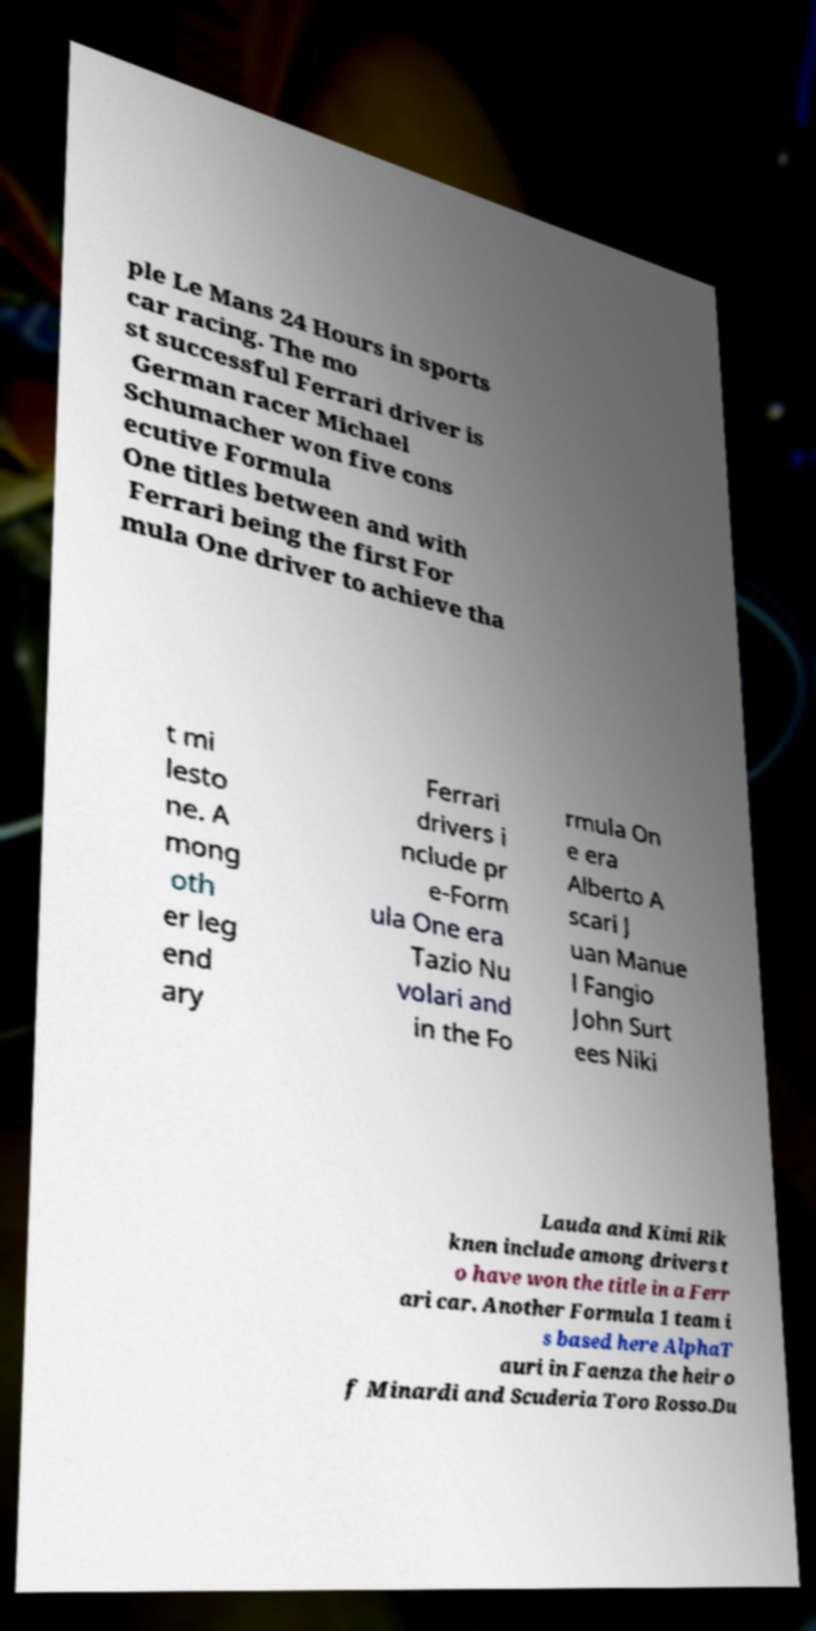Could you assist in decoding the text presented in this image and type it out clearly? ple Le Mans 24 Hours in sports car racing. The mo st successful Ferrari driver is German racer Michael Schumacher won five cons ecutive Formula One titles between and with Ferrari being the first For mula One driver to achieve tha t mi lesto ne. A mong oth er leg end ary Ferrari drivers i nclude pr e-Form ula One era Tazio Nu volari and in the Fo rmula On e era Alberto A scari J uan Manue l Fangio John Surt ees Niki Lauda and Kimi Rik knen include among drivers t o have won the title in a Ferr ari car. Another Formula 1 team i s based here AlphaT auri in Faenza the heir o f Minardi and Scuderia Toro Rosso.Du 